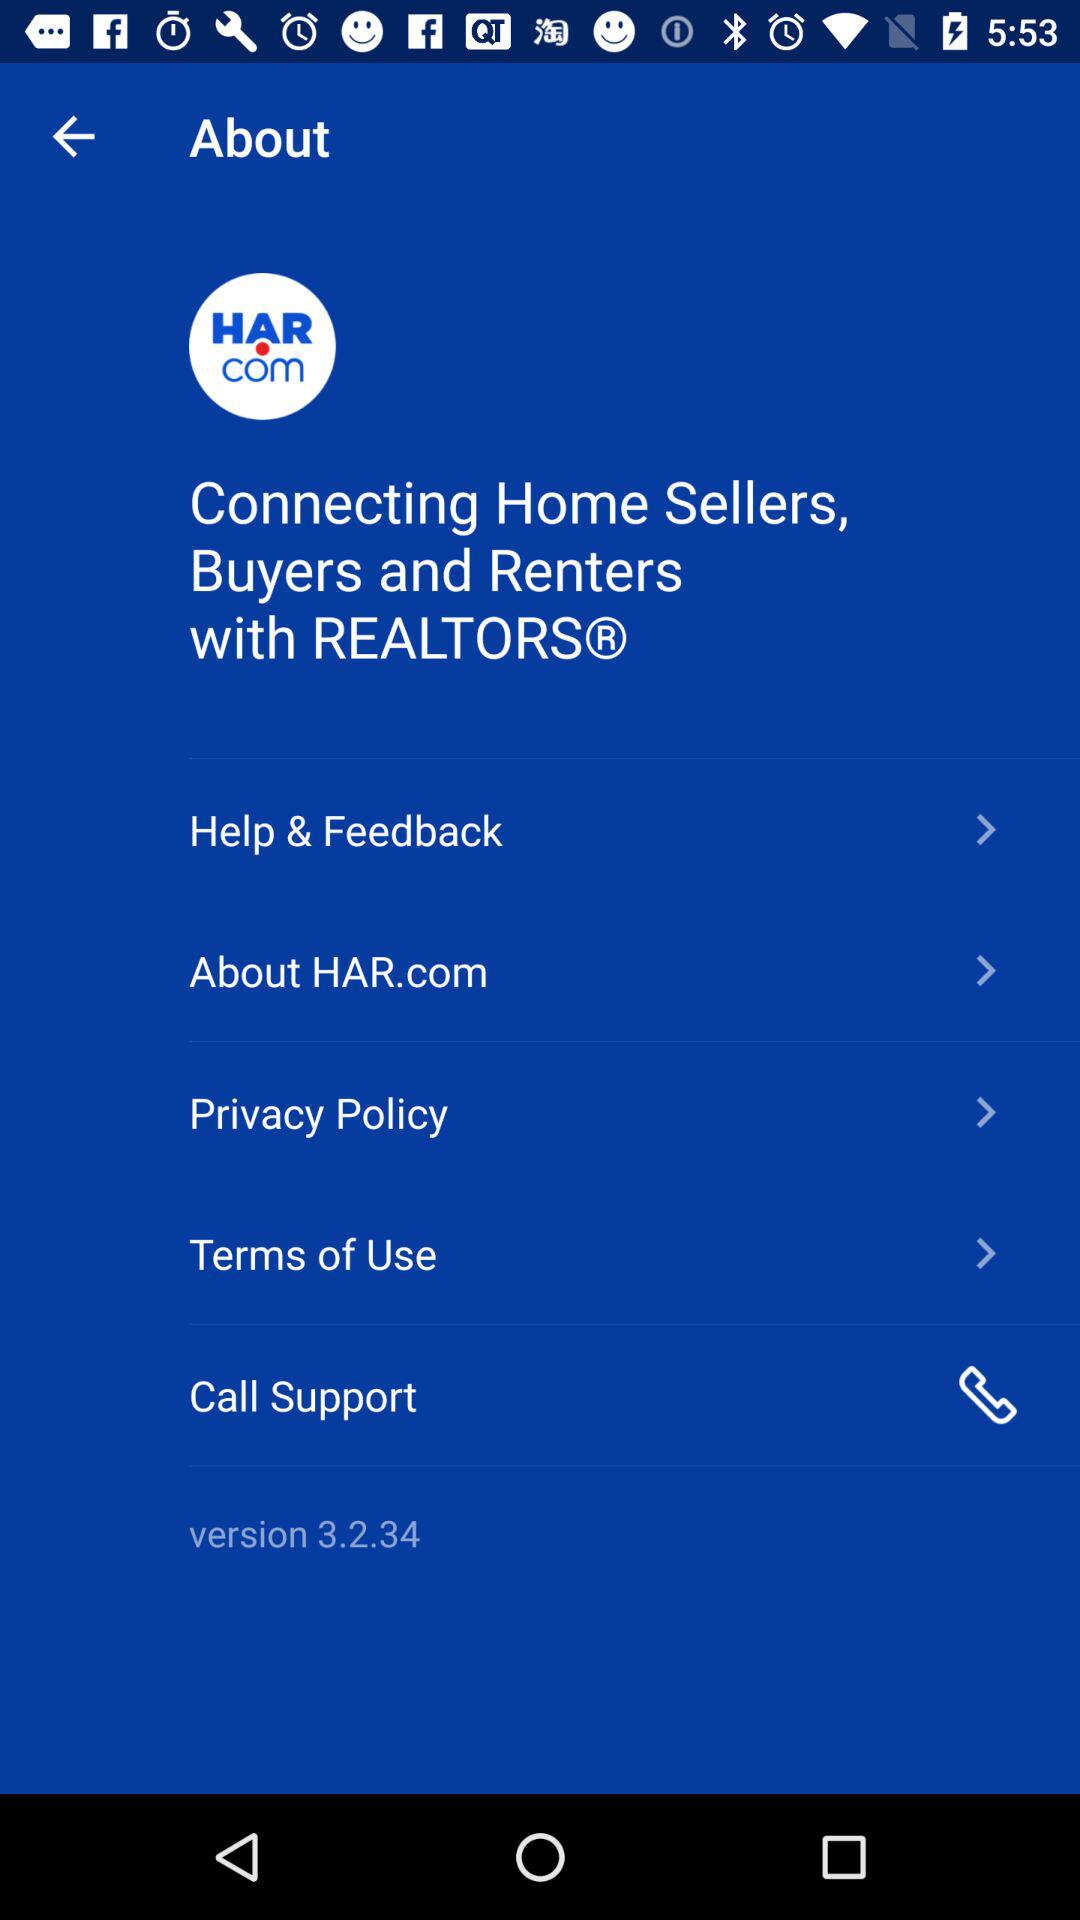When was the latest feedback sent?
When the provided information is insufficient, respond with <no answer>. <no answer> 